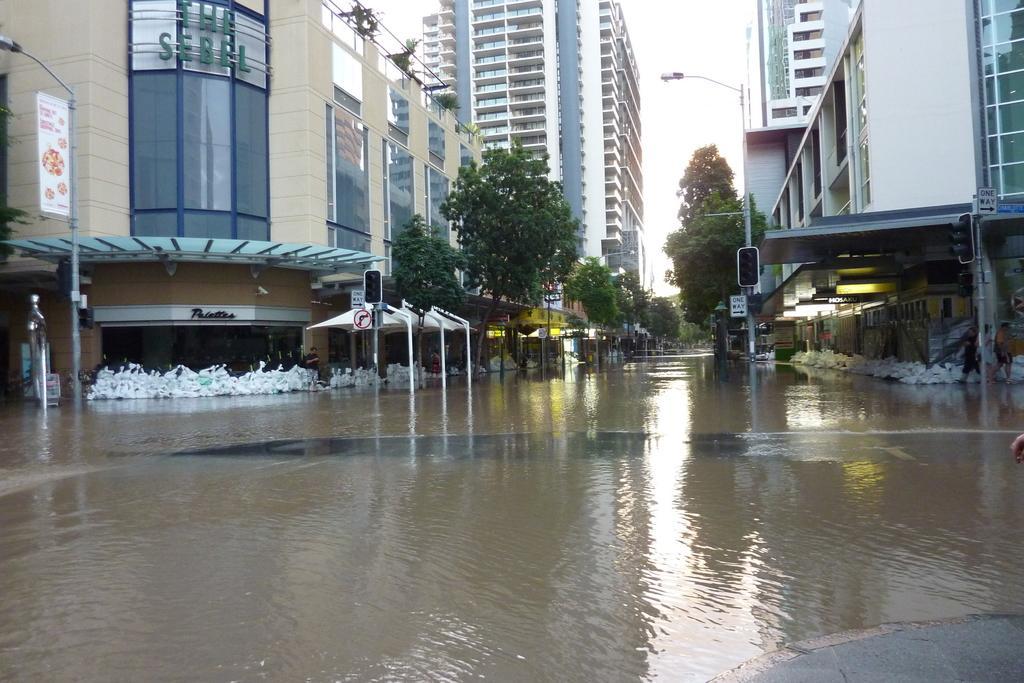Please provide a concise description of this image. In this image in the front there is water on the road. In the background there are buildings, trees and poles. 